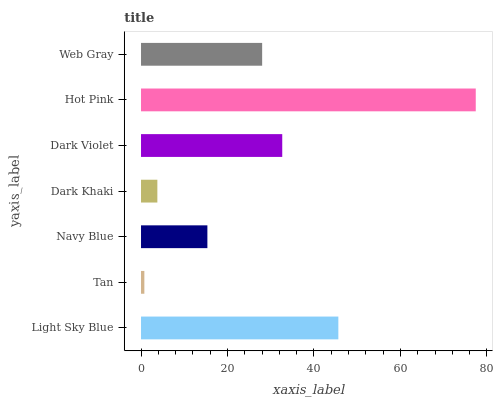Is Tan the minimum?
Answer yes or no. Yes. Is Hot Pink the maximum?
Answer yes or no. Yes. Is Navy Blue the minimum?
Answer yes or no. No. Is Navy Blue the maximum?
Answer yes or no. No. Is Navy Blue greater than Tan?
Answer yes or no. Yes. Is Tan less than Navy Blue?
Answer yes or no. Yes. Is Tan greater than Navy Blue?
Answer yes or no. No. Is Navy Blue less than Tan?
Answer yes or no. No. Is Web Gray the high median?
Answer yes or no. Yes. Is Web Gray the low median?
Answer yes or no. Yes. Is Navy Blue the high median?
Answer yes or no. No. Is Hot Pink the low median?
Answer yes or no. No. 